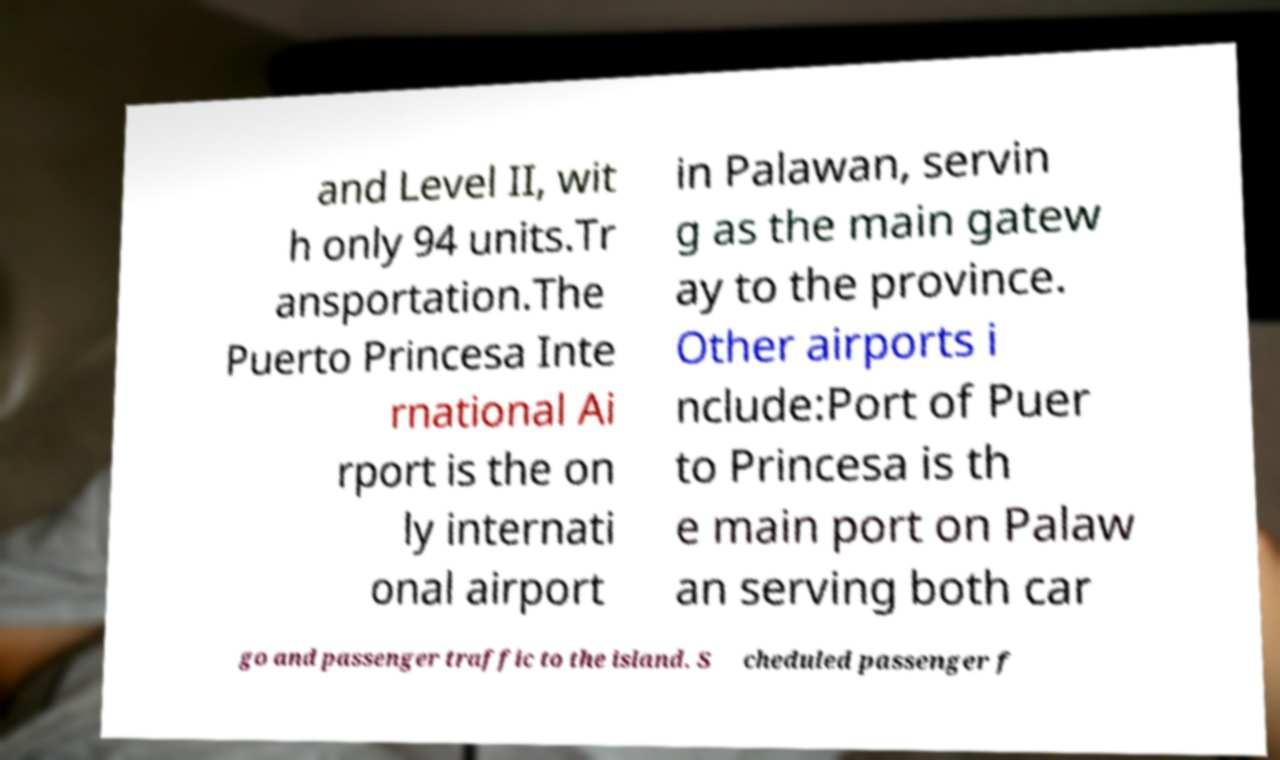What messages or text are displayed in this image? I need them in a readable, typed format. and Level II, wit h only 94 units.Tr ansportation.The Puerto Princesa Inte rnational Ai rport is the on ly internati onal airport in Palawan, servin g as the main gatew ay to the province. Other airports i nclude:Port of Puer to Princesa is th e main port on Palaw an serving both car go and passenger traffic to the island. S cheduled passenger f 